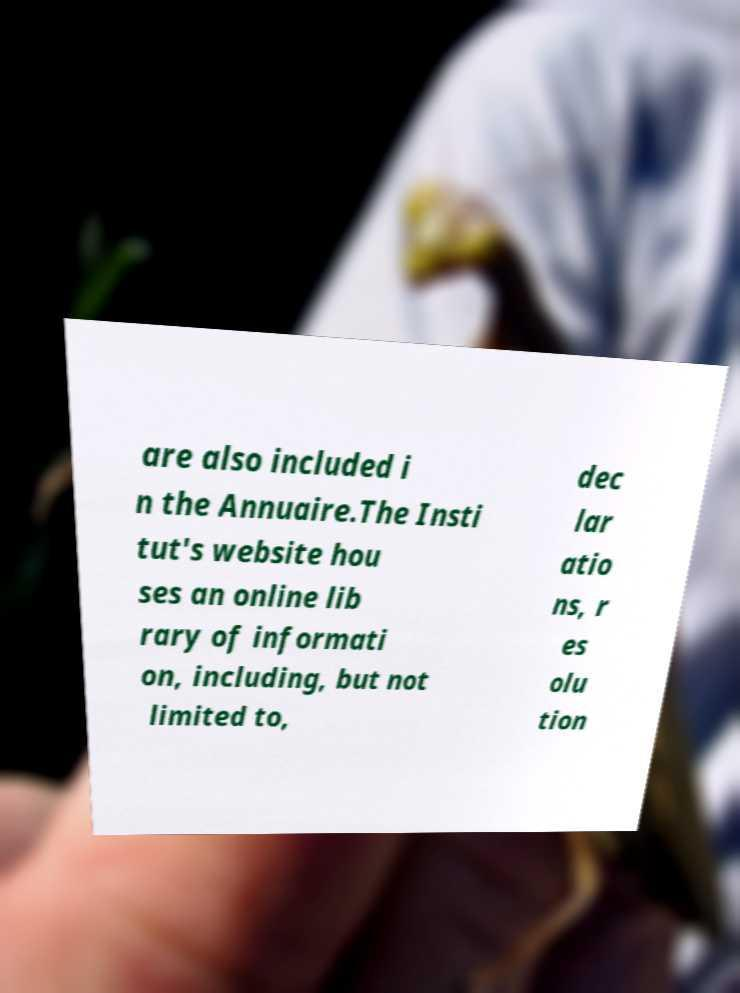There's text embedded in this image that I need extracted. Can you transcribe it verbatim? are also included i n the Annuaire.The Insti tut's website hou ses an online lib rary of informati on, including, but not limited to, dec lar atio ns, r es olu tion 